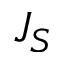Convert formula to latex. <formula><loc_0><loc_0><loc_500><loc_500>J _ { S }</formula> 